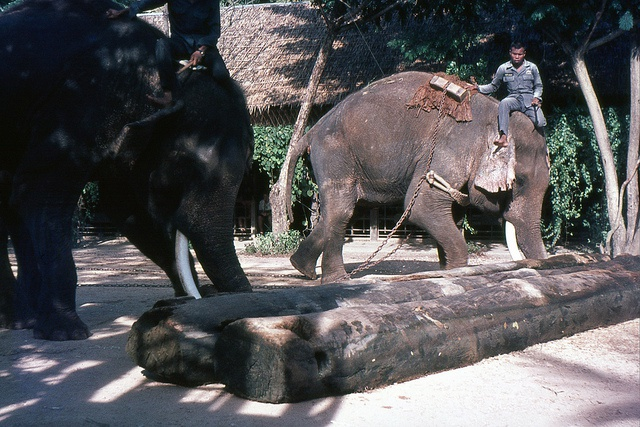Describe the objects in this image and their specific colors. I can see elephant in black, gray, and darkgray tones, elephant in black, gray, and darkgray tones, people in black, gray, navy, and darkgray tones, people in black, darkgray, and gray tones, and people in black, gray, and purple tones in this image. 